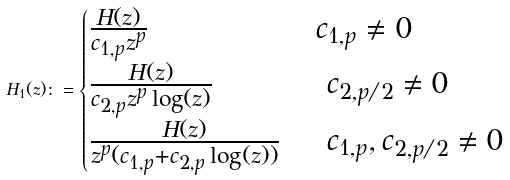Convert formula to latex. <formula><loc_0><loc_0><loc_500><loc_500>H _ { 1 } ( z ) \colon = \begin{cases} \frac { H ( z ) } { c _ { 1 , p } z ^ { p } } & \, c _ { 1 , p } \neq 0 \\ \frac { H ( z ) } { c _ { 2 , p } z ^ { p } \log ( z ) } & \, \ c _ { 2 , p / 2 } \neq 0 \\ \frac { H ( z ) } { z ^ { p } ( c _ { 1 , p } + c _ { 2 , p } \log ( z ) ) } & \, \ c _ { 1 , p } , c _ { 2 , p / 2 } \neq 0 \\ \end{cases}</formula> 